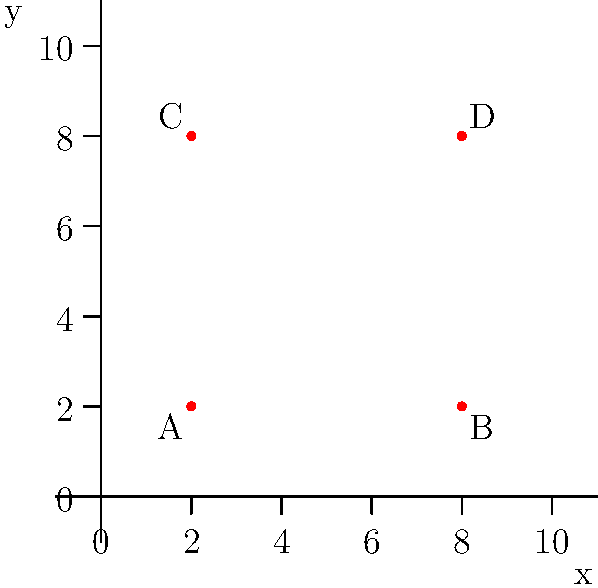As a wrestling promoter, you're planning a new arena layout. The coordinate grid above represents the seating area, where each unit equals 10 feet. Points A(2,2), B(8,2), C(2,8), and D(8,8) mark the corners of the optimal seating arrangement. Calculate the total area of the seating arrangement in square feet. To find the area of the seating arrangement, we need to follow these steps:

1. Identify the shape: The points form a square on the coordinate grid.

2. Calculate the side length:
   We can find this by calculating the distance between two adjacent points, such as A and B.
   Using the distance formula: $d = \sqrt{(x_2-x_1)^2 + (y_2-y_1)^2}$
   $d = \sqrt{(8-2)^2 + (2-2)^2} = \sqrt{36 + 0} = 6$ units

3. Convert units to feet:
   Each unit on the grid represents 10 feet, so the side length is:
   $6 \times 10 = 60$ feet

4. Calculate the area:
   Area of a square = side length squared
   $A = 60^2 = 3600$ square feet

Therefore, the total area of the seating arrangement is 3600 square feet.
Answer: 3600 square feet 